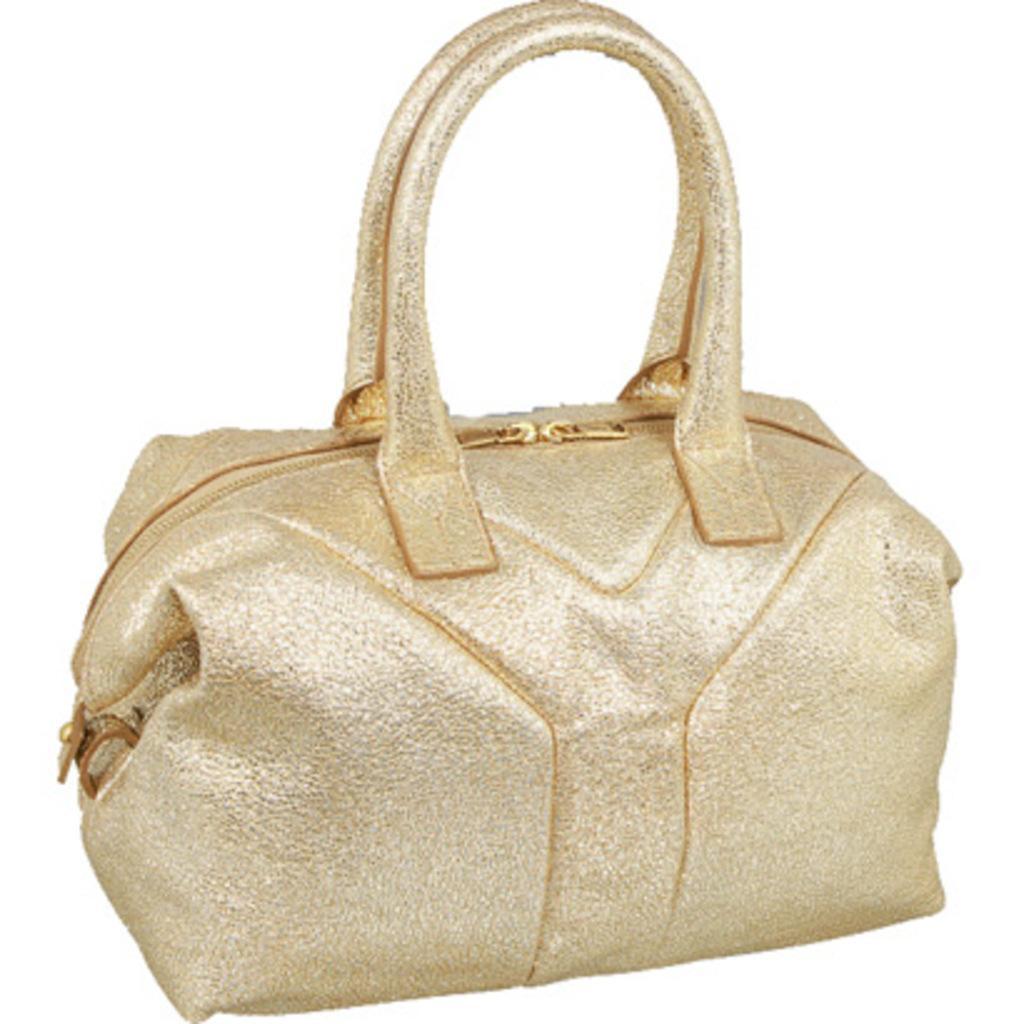Please provide a concise description of this image. In this image there is purse which in gold color. Background of the purse is in white. 